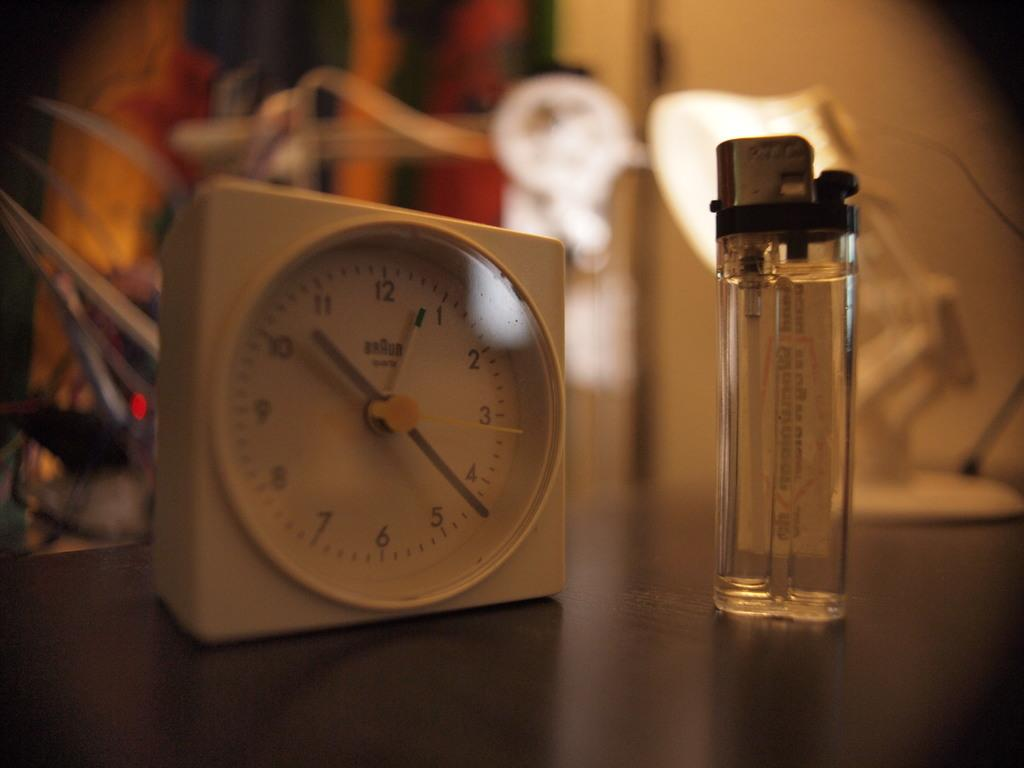Provide a one-sentence caption for the provided image. A small white Braun brand clock sits next to a lighter on a table. 